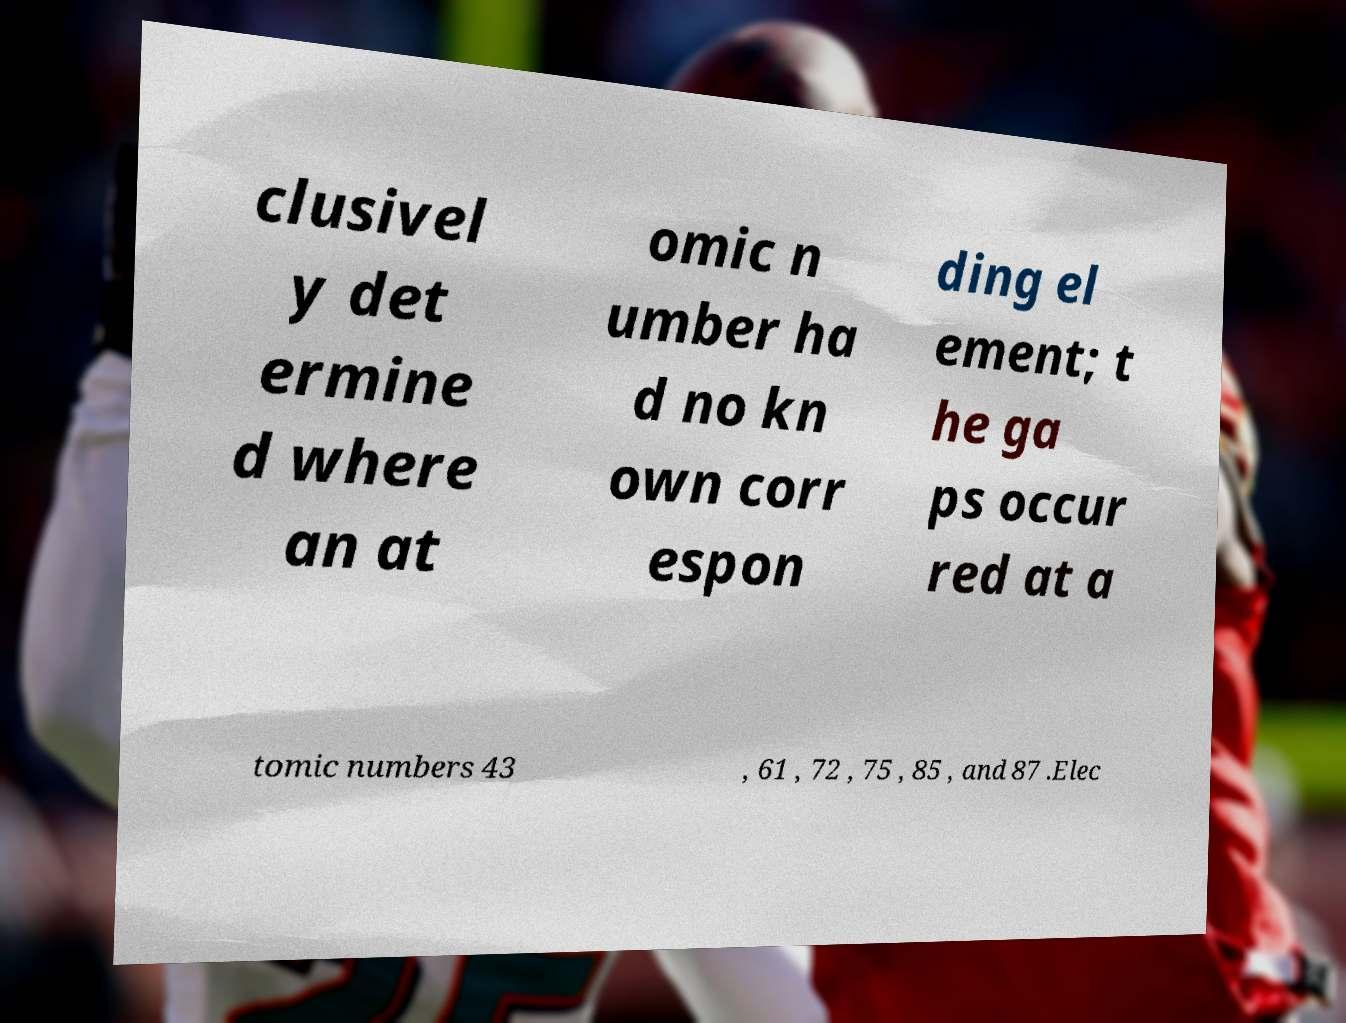There's text embedded in this image that I need extracted. Can you transcribe it verbatim? clusivel y det ermine d where an at omic n umber ha d no kn own corr espon ding el ement; t he ga ps occur red at a tomic numbers 43 , 61 , 72 , 75 , 85 , and 87 .Elec 